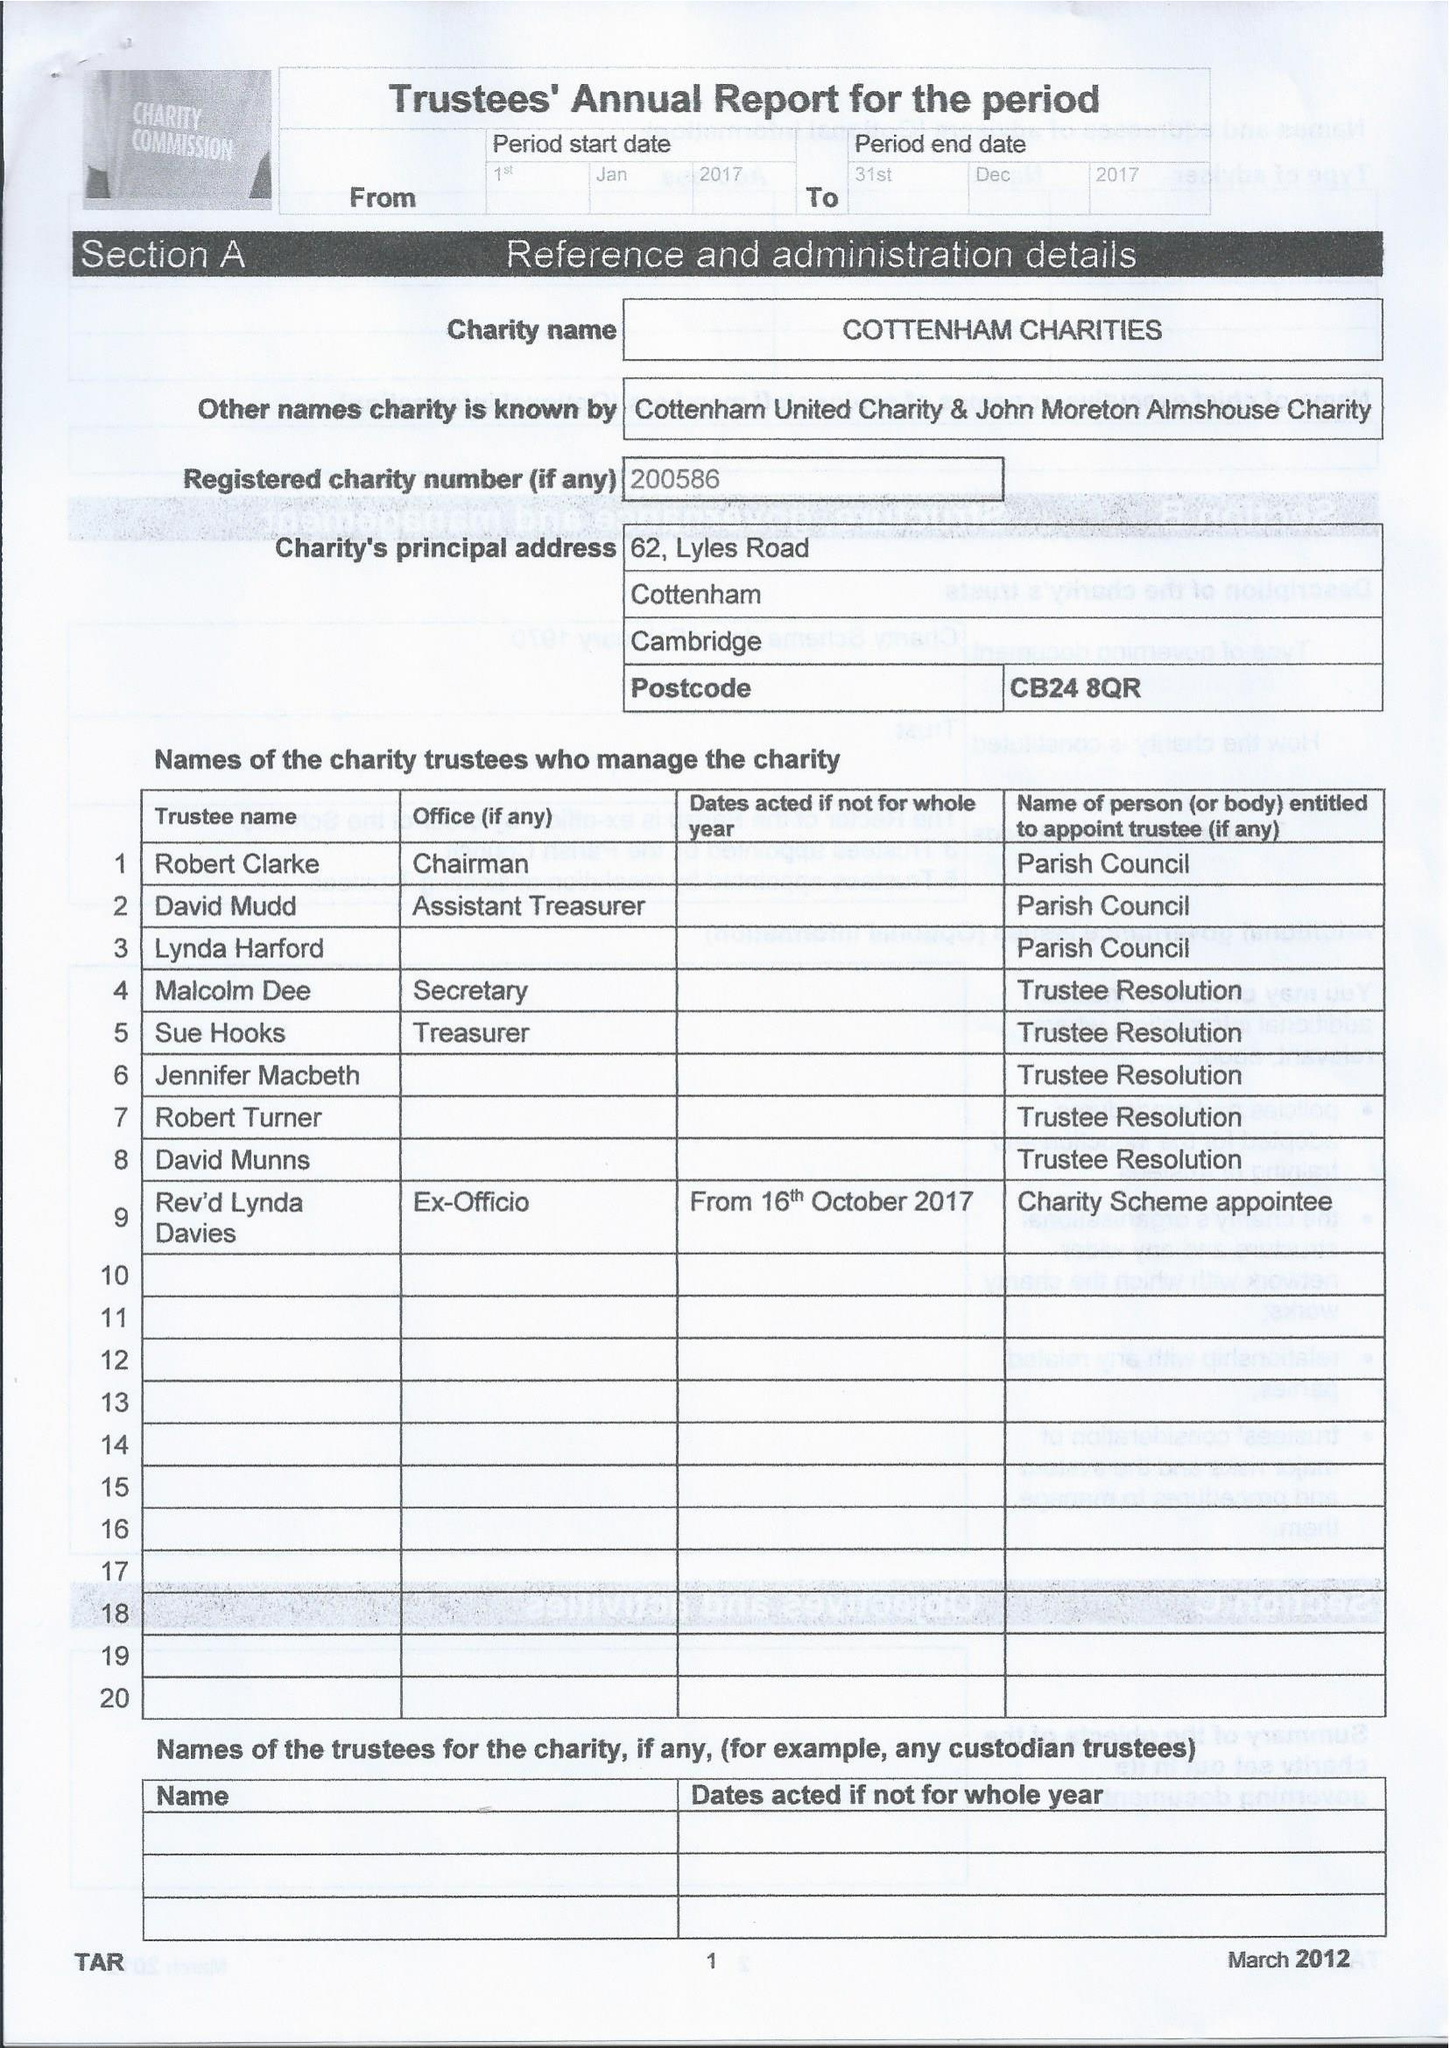What is the value for the spending_annually_in_british_pounds?
Answer the question using a single word or phrase. 29226.00 